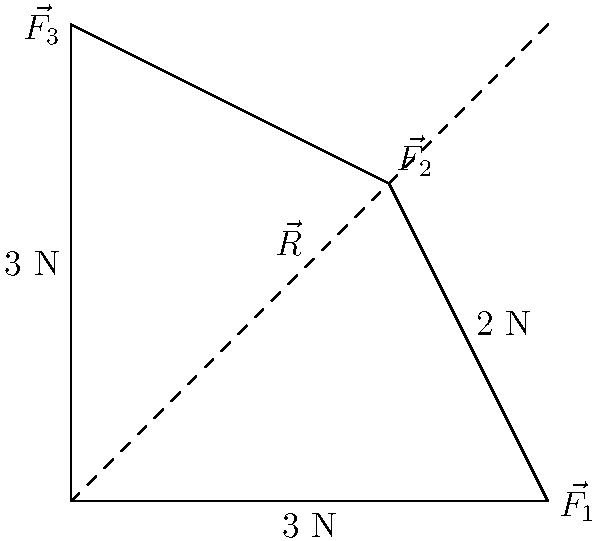In a force diagram, three force vectors $\vec{F_1}$, $\vec{F_2}$, and $\vec{F_3}$ are acting on a point. $\vec{F_1}$ has a magnitude of 3 N and acts along the positive x-axis, $\vec{F_2}$ has a magnitude of 2 N and acts at a 45° angle to the positive x-axis, and $\vec{F_3}$ has a magnitude of 3 N and acts along the positive y-axis. Calculate the magnitude of the resultant force vector $\vec{R}$ using C++ and the cmath library. To solve this problem, we'll follow these steps:

1. Decompose the forces into their x and y components:
   $F_{1x} = 3$ N, $F_{1y} = 0$ N
   $F_{2x} = 2 \cos(45°) = 2 \cdot \frac{\sqrt{2}}{2}$ N
   $F_{2y} = 2 \sin(45°) = 2 \cdot \frac{\sqrt{2}}{2}$ N
   $F_{3x} = 0$ N, $F_{3y} = 3$ N

2. Sum the x and y components:
   $R_x = F_{1x} + F_{2x} + F_{3x} = 3 + 2 \cdot \frac{\sqrt{2}}{2} + 0$ N
   $R_y = F_{1y} + F_{2y} + F_{3y} = 0 + 2 \cdot \frac{\sqrt{2}}{2} + 3$ N

3. Calculate the magnitude of the resultant vector using the Pythagorean theorem:
   $|\vec{R}| = \sqrt{R_x^2 + R_y^2}$

In C++, we can implement this calculation as follows:

```cpp
#include <iostream>
#include <cmath>

int main() {
    const double sqrt2 = std::sqrt(2);
    double Rx = 3 + 2 * sqrt2 / 2;
    double Ry = 2 * sqrt2 / 2 + 3;
    double R = std::sqrt(Rx * Rx + Ry * Ry);
    std::cout << "Magnitude of resultant force: " << R << " N" << std::endl;
    return 0;
}
```

This code calculates the magnitude of the resultant force vector $\vec{R}$.
Answer: $|\vec{R}| = \sqrt{(3 + \sqrt{2})^2 + (3 + \sqrt{2})^2} \approx 5.74$ N 